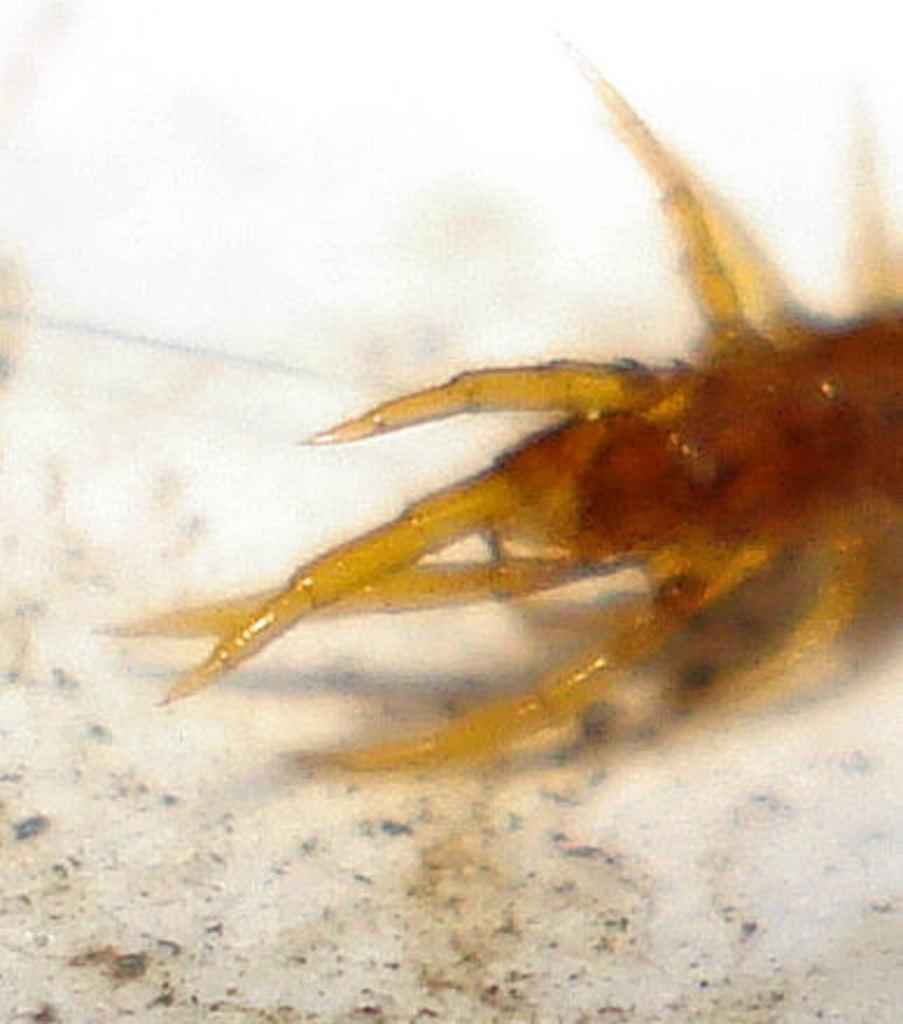How would you summarize this image in a sentence or two? In this image I can see an insect on the ground. This image is taken may be during a day. 